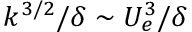Convert formula to latex. <formula><loc_0><loc_0><loc_500><loc_500>k ^ { 3 / 2 } / \delta \sim U _ { e } ^ { 3 } / \delta</formula> 